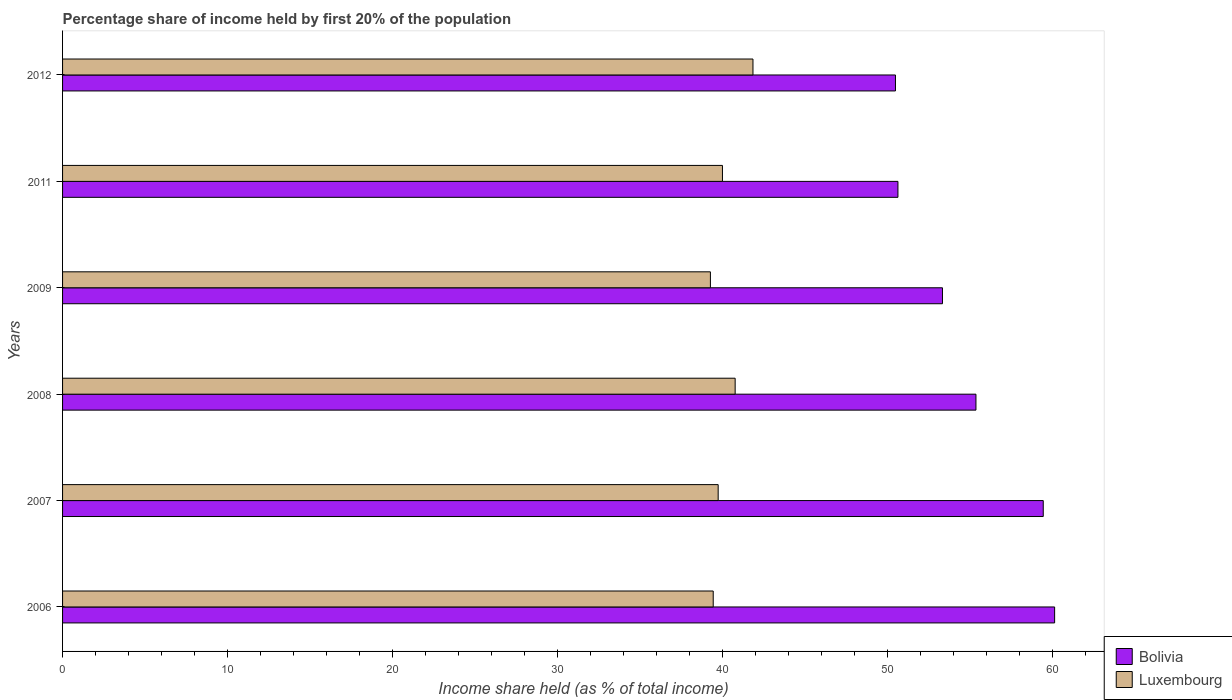Are the number of bars per tick equal to the number of legend labels?
Make the answer very short. Yes. Are the number of bars on each tick of the Y-axis equal?
Your answer should be very brief. Yes. How many bars are there on the 3rd tick from the top?
Ensure brevity in your answer.  2. What is the share of income held by first 20% of the population in Bolivia in 2007?
Offer a very short reply. 59.46. Across all years, what is the maximum share of income held by first 20% of the population in Bolivia?
Provide a succinct answer. 60.15. Across all years, what is the minimum share of income held by first 20% of the population in Luxembourg?
Provide a succinct answer. 39.28. What is the total share of income held by first 20% of the population in Bolivia in the graph?
Make the answer very short. 329.49. What is the difference between the share of income held by first 20% of the population in Luxembourg in 2011 and the share of income held by first 20% of the population in Bolivia in 2007?
Your answer should be very brief. -19.45. What is the average share of income held by first 20% of the population in Bolivia per year?
Offer a terse response. 54.91. In the year 2009, what is the difference between the share of income held by first 20% of the population in Luxembourg and share of income held by first 20% of the population in Bolivia?
Give a very brief answer. -14.07. What is the ratio of the share of income held by first 20% of the population in Bolivia in 2009 to that in 2012?
Make the answer very short. 1.06. What is the difference between the highest and the second highest share of income held by first 20% of the population in Luxembourg?
Offer a very short reply. 1.08. What is the difference between the highest and the lowest share of income held by first 20% of the population in Bolivia?
Provide a succinct answer. 9.65. In how many years, is the share of income held by first 20% of the population in Bolivia greater than the average share of income held by first 20% of the population in Bolivia taken over all years?
Give a very brief answer. 3. What does the 1st bar from the top in 2007 represents?
Keep it short and to the point. Luxembourg. What does the 2nd bar from the bottom in 2007 represents?
Keep it short and to the point. Luxembourg. How many bars are there?
Your answer should be compact. 12. What is the difference between two consecutive major ticks on the X-axis?
Your answer should be very brief. 10. Are the values on the major ticks of X-axis written in scientific E-notation?
Your answer should be compact. No. Does the graph contain any zero values?
Ensure brevity in your answer.  No. How many legend labels are there?
Provide a succinct answer. 2. What is the title of the graph?
Ensure brevity in your answer.  Percentage share of income held by first 20% of the population. What is the label or title of the X-axis?
Ensure brevity in your answer.  Income share held (as % of total income). What is the Income share held (as % of total income) of Bolivia in 2006?
Keep it short and to the point. 60.15. What is the Income share held (as % of total income) of Luxembourg in 2006?
Offer a very short reply. 39.45. What is the Income share held (as % of total income) of Bolivia in 2007?
Keep it short and to the point. 59.46. What is the Income share held (as % of total income) in Luxembourg in 2007?
Give a very brief answer. 39.75. What is the Income share held (as % of total income) in Bolivia in 2008?
Give a very brief answer. 55.38. What is the Income share held (as % of total income) of Luxembourg in 2008?
Keep it short and to the point. 40.78. What is the Income share held (as % of total income) in Bolivia in 2009?
Your response must be concise. 53.35. What is the Income share held (as % of total income) in Luxembourg in 2009?
Give a very brief answer. 39.28. What is the Income share held (as % of total income) of Bolivia in 2011?
Ensure brevity in your answer.  50.65. What is the Income share held (as % of total income) in Luxembourg in 2011?
Your response must be concise. 40.01. What is the Income share held (as % of total income) in Bolivia in 2012?
Offer a terse response. 50.5. What is the Income share held (as % of total income) in Luxembourg in 2012?
Offer a terse response. 41.86. Across all years, what is the maximum Income share held (as % of total income) in Bolivia?
Make the answer very short. 60.15. Across all years, what is the maximum Income share held (as % of total income) of Luxembourg?
Make the answer very short. 41.86. Across all years, what is the minimum Income share held (as % of total income) in Bolivia?
Ensure brevity in your answer.  50.5. Across all years, what is the minimum Income share held (as % of total income) in Luxembourg?
Offer a terse response. 39.28. What is the total Income share held (as % of total income) of Bolivia in the graph?
Your answer should be very brief. 329.49. What is the total Income share held (as % of total income) in Luxembourg in the graph?
Ensure brevity in your answer.  241.13. What is the difference between the Income share held (as % of total income) in Bolivia in 2006 and that in 2007?
Give a very brief answer. 0.69. What is the difference between the Income share held (as % of total income) of Bolivia in 2006 and that in 2008?
Make the answer very short. 4.77. What is the difference between the Income share held (as % of total income) in Luxembourg in 2006 and that in 2008?
Ensure brevity in your answer.  -1.33. What is the difference between the Income share held (as % of total income) in Bolivia in 2006 and that in 2009?
Ensure brevity in your answer.  6.8. What is the difference between the Income share held (as % of total income) in Luxembourg in 2006 and that in 2009?
Your response must be concise. 0.17. What is the difference between the Income share held (as % of total income) of Bolivia in 2006 and that in 2011?
Offer a terse response. 9.5. What is the difference between the Income share held (as % of total income) in Luxembourg in 2006 and that in 2011?
Your response must be concise. -0.56. What is the difference between the Income share held (as % of total income) of Bolivia in 2006 and that in 2012?
Offer a terse response. 9.65. What is the difference between the Income share held (as % of total income) of Luxembourg in 2006 and that in 2012?
Your response must be concise. -2.41. What is the difference between the Income share held (as % of total income) of Bolivia in 2007 and that in 2008?
Your response must be concise. 4.08. What is the difference between the Income share held (as % of total income) in Luxembourg in 2007 and that in 2008?
Your response must be concise. -1.03. What is the difference between the Income share held (as % of total income) in Bolivia in 2007 and that in 2009?
Make the answer very short. 6.11. What is the difference between the Income share held (as % of total income) of Luxembourg in 2007 and that in 2009?
Your answer should be very brief. 0.47. What is the difference between the Income share held (as % of total income) in Bolivia in 2007 and that in 2011?
Ensure brevity in your answer.  8.81. What is the difference between the Income share held (as % of total income) in Luxembourg in 2007 and that in 2011?
Provide a short and direct response. -0.26. What is the difference between the Income share held (as % of total income) in Bolivia in 2007 and that in 2012?
Your response must be concise. 8.96. What is the difference between the Income share held (as % of total income) of Luxembourg in 2007 and that in 2012?
Provide a succinct answer. -2.11. What is the difference between the Income share held (as % of total income) of Bolivia in 2008 and that in 2009?
Ensure brevity in your answer.  2.03. What is the difference between the Income share held (as % of total income) of Luxembourg in 2008 and that in 2009?
Provide a short and direct response. 1.5. What is the difference between the Income share held (as % of total income) of Bolivia in 2008 and that in 2011?
Make the answer very short. 4.73. What is the difference between the Income share held (as % of total income) of Luxembourg in 2008 and that in 2011?
Your response must be concise. 0.77. What is the difference between the Income share held (as % of total income) in Bolivia in 2008 and that in 2012?
Give a very brief answer. 4.88. What is the difference between the Income share held (as % of total income) of Luxembourg in 2008 and that in 2012?
Your answer should be compact. -1.08. What is the difference between the Income share held (as % of total income) of Bolivia in 2009 and that in 2011?
Ensure brevity in your answer.  2.7. What is the difference between the Income share held (as % of total income) of Luxembourg in 2009 and that in 2011?
Ensure brevity in your answer.  -0.73. What is the difference between the Income share held (as % of total income) in Bolivia in 2009 and that in 2012?
Give a very brief answer. 2.85. What is the difference between the Income share held (as % of total income) of Luxembourg in 2009 and that in 2012?
Make the answer very short. -2.58. What is the difference between the Income share held (as % of total income) of Luxembourg in 2011 and that in 2012?
Provide a short and direct response. -1.85. What is the difference between the Income share held (as % of total income) in Bolivia in 2006 and the Income share held (as % of total income) in Luxembourg in 2007?
Make the answer very short. 20.4. What is the difference between the Income share held (as % of total income) of Bolivia in 2006 and the Income share held (as % of total income) of Luxembourg in 2008?
Offer a very short reply. 19.37. What is the difference between the Income share held (as % of total income) in Bolivia in 2006 and the Income share held (as % of total income) in Luxembourg in 2009?
Give a very brief answer. 20.87. What is the difference between the Income share held (as % of total income) in Bolivia in 2006 and the Income share held (as % of total income) in Luxembourg in 2011?
Offer a very short reply. 20.14. What is the difference between the Income share held (as % of total income) of Bolivia in 2006 and the Income share held (as % of total income) of Luxembourg in 2012?
Your answer should be very brief. 18.29. What is the difference between the Income share held (as % of total income) in Bolivia in 2007 and the Income share held (as % of total income) in Luxembourg in 2008?
Keep it short and to the point. 18.68. What is the difference between the Income share held (as % of total income) of Bolivia in 2007 and the Income share held (as % of total income) of Luxembourg in 2009?
Offer a very short reply. 20.18. What is the difference between the Income share held (as % of total income) of Bolivia in 2007 and the Income share held (as % of total income) of Luxembourg in 2011?
Your response must be concise. 19.45. What is the difference between the Income share held (as % of total income) of Bolivia in 2008 and the Income share held (as % of total income) of Luxembourg in 2009?
Your response must be concise. 16.1. What is the difference between the Income share held (as % of total income) of Bolivia in 2008 and the Income share held (as % of total income) of Luxembourg in 2011?
Your answer should be compact. 15.37. What is the difference between the Income share held (as % of total income) of Bolivia in 2008 and the Income share held (as % of total income) of Luxembourg in 2012?
Give a very brief answer. 13.52. What is the difference between the Income share held (as % of total income) in Bolivia in 2009 and the Income share held (as % of total income) in Luxembourg in 2011?
Your answer should be compact. 13.34. What is the difference between the Income share held (as % of total income) in Bolivia in 2009 and the Income share held (as % of total income) in Luxembourg in 2012?
Provide a short and direct response. 11.49. What is the difference between the Income share held (as % of total income) of Bolivia in 2011 and the Income share held (as % of total income) of Luxembourg in 2012?
Keep it short and to the point. 8.79. What is the average Income share held (as % of total income) in Bolivia per year?
Offer a very short reply. 54.91. What is the average Income share held (as % of total income) of Luxembourg per year?
Give a very brief answer. 40.19. In the year 2006, what is the difference between the Income share held (as % of total income) of Bolivia and Income share held (as % of total income) of Luxembourg?
Your answer should be compact. 20.7. In the year 2007, what is the difference between the Income share held (as % of total income) of Bolivia and Income share held (as % of total income) of Luxembourg?
Keep it short and to the point. 19.71. In the year 2008, what is the difference between the Income share held (as % of total income) in Bolivia and Income share held (as % of total income) in Luxembourg?
Offer a terse response. 14.6. In the year 2009, what is the difference between the Income share held (as % of total income) in Bolivia and Income share held (as % of total income) in Luxembourg?
Provide a succinct answer. 14.07. In the year 2011, what is the difference between the Income share held (as % of total income) in Bolivia and Income share held (as % of total income) in Luxembourg?
Provide a short and direct response. 10.64. In the year 2012, what is the difference between the Income share held (as % of total income) of Bolivia and Income share held (as % of total income) of Luxembourg?
Keep it short and to the point. 8.64. What is the ratio of the Income share held (as % of total income) in Bolivia in 2006 to that in 2007?
Your answer should be very brief. 1.01. What is the ratio of the Income share held (as % of total income) of Bolivia in 2006 to that in 2008?
Your response must be concise. 1.09. What is the ratio of the Income share held (as % of total income) of Luxembourg in 2006 to that in 2008?
Give a very brief answer. 0.97. What is the ratio of the Income share held (as % of total income) in Bolivia in 2006 to that in 2009?
Offer a very short reply. 1.13. What is the ratio of the Income share held (as % of total income) of Bolivia in 2006 to that in 2011?
Provide a short and direct response. 1.19. What is the ratio of the Income share held (as % of total income) of Luxembourg in 2006 to that in 2011?
Give a very brief answer. 0.99. What is the ratio of the Income share held (as % of total income) in Bolivia in 2006 to that in 2012?
Provide a succinct answer. 1.19. What is the ratio of the Income share held (as % of total income) of Luxembourg in 2006 to that in 2012?
Your answer should be compact. 0.94. What is the ratio of the Income share held (as % of total income) in Bolivia in 2007 to that in 2008?
Make the answer very short. 1.07. What is the ratio of the Income share held (as % of total income) in Luxembourg in 2007 to that in 2008?
Your response must be concise. 0.97. What is the ratio of the Income share held (as % of total income) in Bolivia in 2007 to that in 2009?
Ensure brevity in your answer.  1.11. What is the ratio of the Income share held (as % of total income) in Luxembourg in 2007 to that in 2009?
Provide a succinct answer. 1.01. What is the ratio of the Income share held (as % of total income) of Bolivia in 2007 to that in 2011?
Provide a short and direct response. 1.17. What is the ratio of the Income share held (as % of total income) of Luxembourg in 2007 to that in 2011?
Your response must be concise. 0.99. What is the ratio of the Income share held (as % of total income) in Bolivia in 2007 to that in 2012?
Make the answer very short. 1.18. What is the ratio of the Income share held (as % of total income) of Luxembourg in 2007 to that in 2012?
Offer a terse response. 0.95. What is the ratio of the Income share held (as % of total income) in Bolivia in 2008 to that in 2009?
Give a very brief answer. 1.04. What is the ratio of the Income share held (as % of total income) of Luxembourg in 2008 to that in 2009?
Your response must be concise. 1.04. What is the ratio of the Income share held (as % of total income) of Bolivia in 2008 to that in 2011?
Give a very brief answer. 1.09. What is the ratio of the Income share held (as % of total income) in Luxembourg in 2008 to that in 2011?
Your answer should be very brief. 1.02. What is the ratio of the Income share held (as % of total income) in Bolivia in 2008 to that in 2012?
Your answer should be very brief. 1.1. What is the ratio of the Income share held (as % of total income) of Luxembourg in 2008 to that in 2012?
Your answer should be compact. 0.97. What is the ratio of the Income share held (as % of total income) of Bolivia in 2009 to that in 2011?
Your answer should be compact. 1.05. What is the ratio of the Income share held (as % of total income) in Luxembourg in 2009 to that in 2011?
Provide a short and direct response. 0.98. What is the ratio of the Income share held (as % of total income) in Bolivia in 2009 to that in 2012?
Give a very brief answer. 1.06. What is the ratio of the Income share held (as % of total income) of Luxembourg in 2009 to that in 2012?
Offer a very short reply. 0.94. What is the ratio of the Income share held (as % of total income) of Luxembourg in 2011 to that in 2012?
Provide a short and direct response. 0.96. What is the difference between the highest and the second highest Income share held (as % of total income) of Bolivia?
Ensure brevity in your answer.  0.69. What is the difference between the highest and the second highest Income share held (as % of total income) of Luxembourg?
Provide a short and direct response. 1.08. What is the difference between the highest and the lowest Income share held (as % of total income) of Bolivia?
Your answer should be very brief. 9.65. What is the difference between the highest and the lowest Income share held (as % of total income) of Luxembourg?
Ensure brevity in your answer.  2.58. 